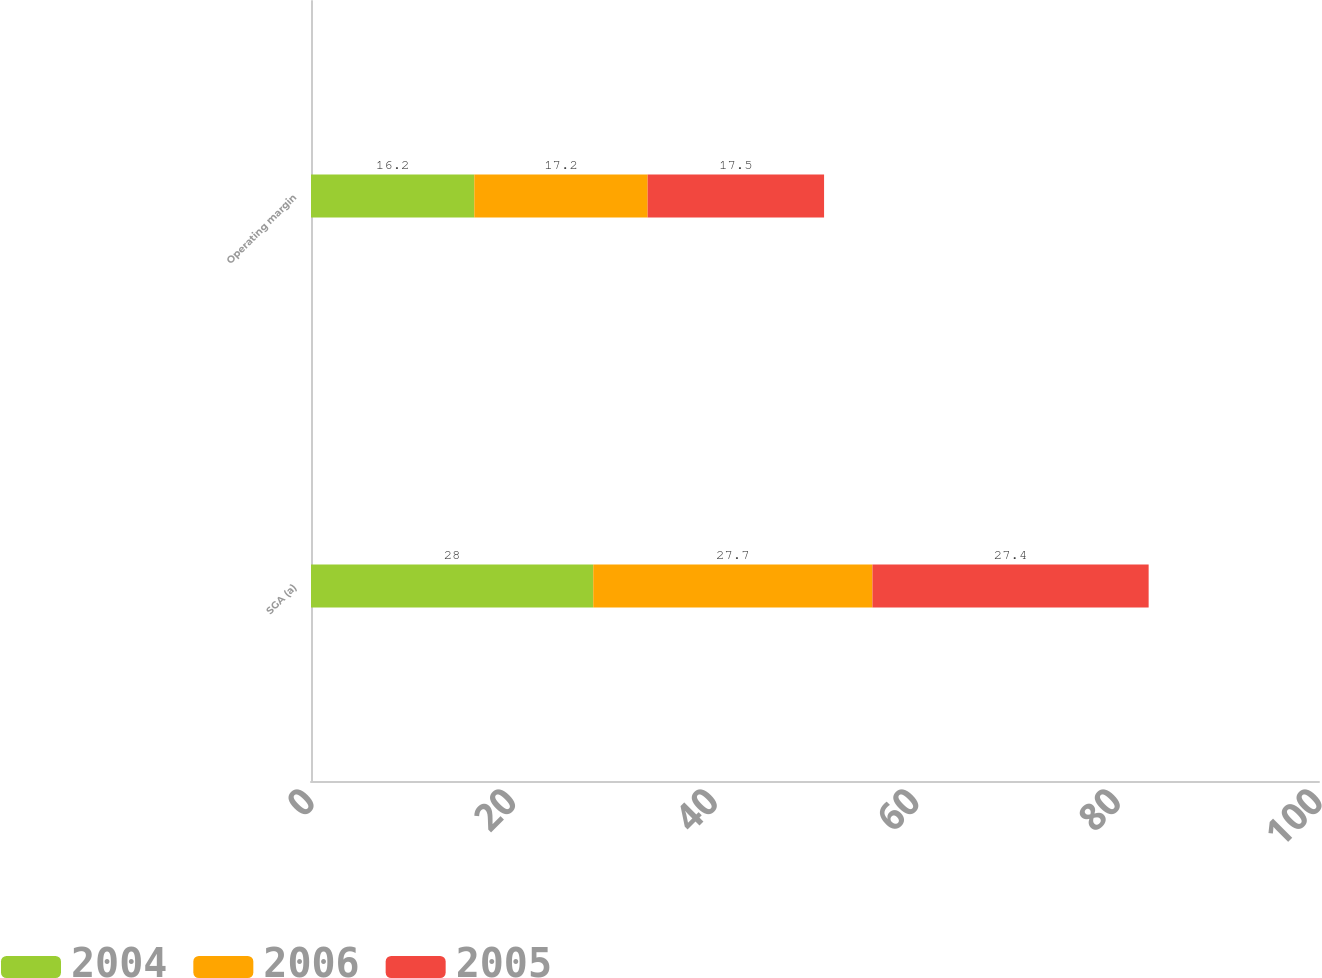<chart> <loc_0><loc_0><loc_500><loc_500><stacked_bar_chart><ecel><fcel>SGA (a)<fcel>Operating margin<nl><fcel>2004<fcel>28<fcel>16.2<nl><fcel>2006<fcel>27.7<fcel>17.2<nl><fcel>2005<fcel>27.4<fcel>17.5<nl></chart> 